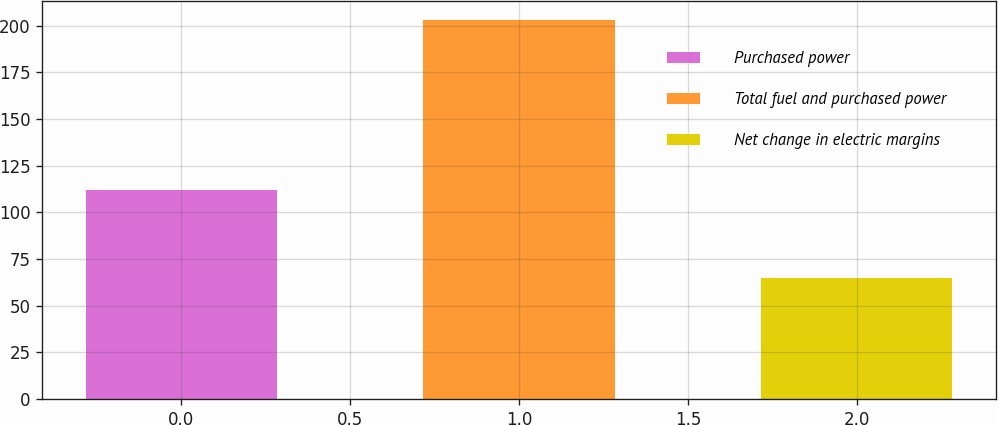Convert chart to OTSL. <chart><loc_0><loc_0><loc_500><loc_500><bar_chart><fcel>Purchased power<fcel>Total fuel and purchased power<fcel>Net change in electric margins<nl><fcel>112<fcel>203<fcel>65<nl></chart> 